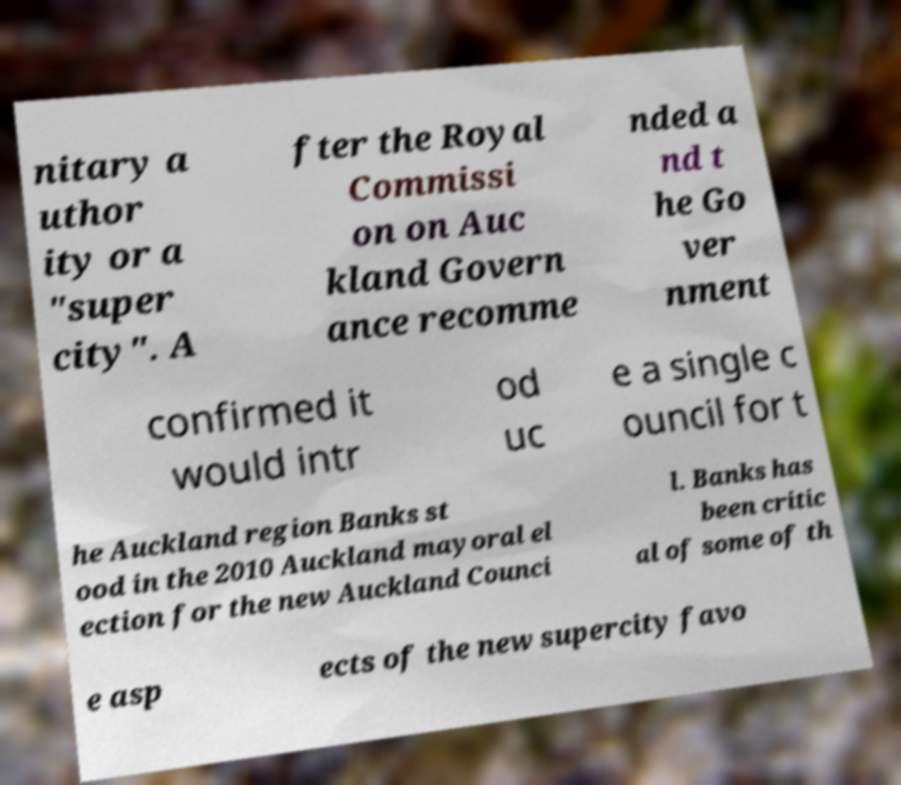I need the written content from this picture converted into text. Can you do that? nitary a uthor ity or a "super city". A fter the Royal Commissi on on Auc kland Govern ance recomme nded a nd t he Go ver nment confirmed it would intr od uc e a single c ouncil for t he Auckland region Banks st ood in the 2010 Auckland mayoral el ection for the new Auckland Counci l. Banks has been critic al of some of th e asp ects of the new supercity favo 